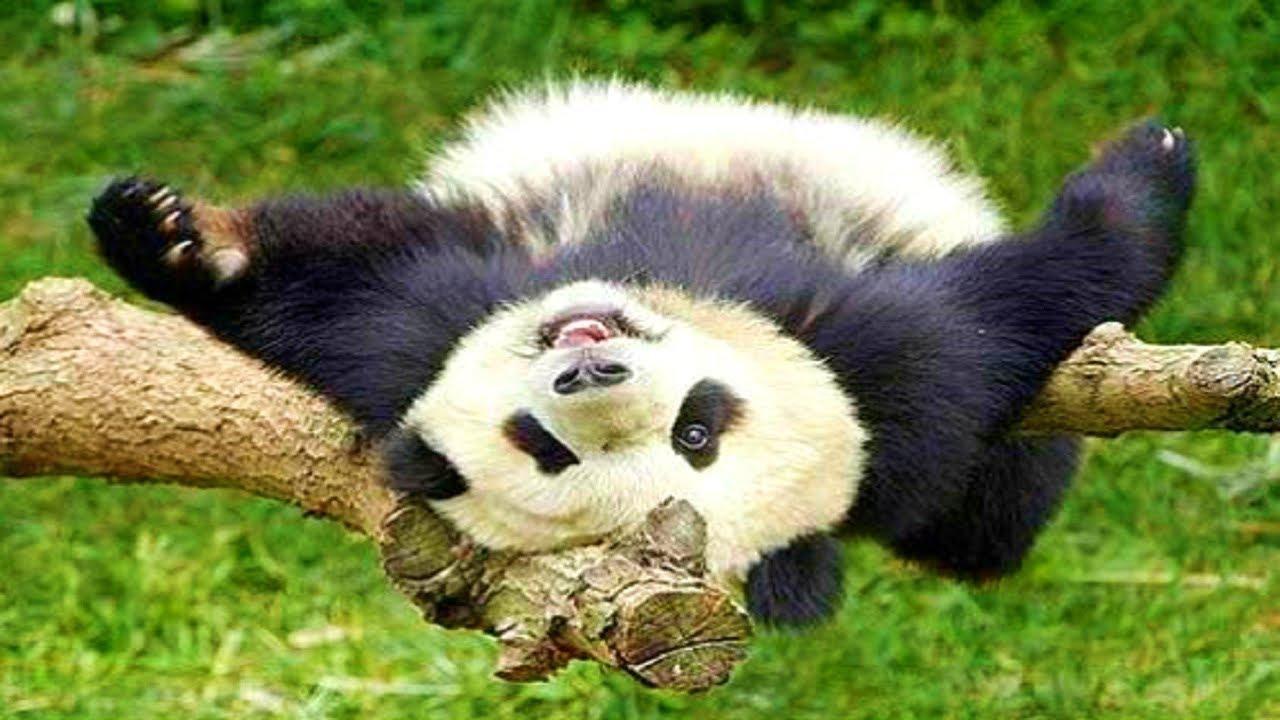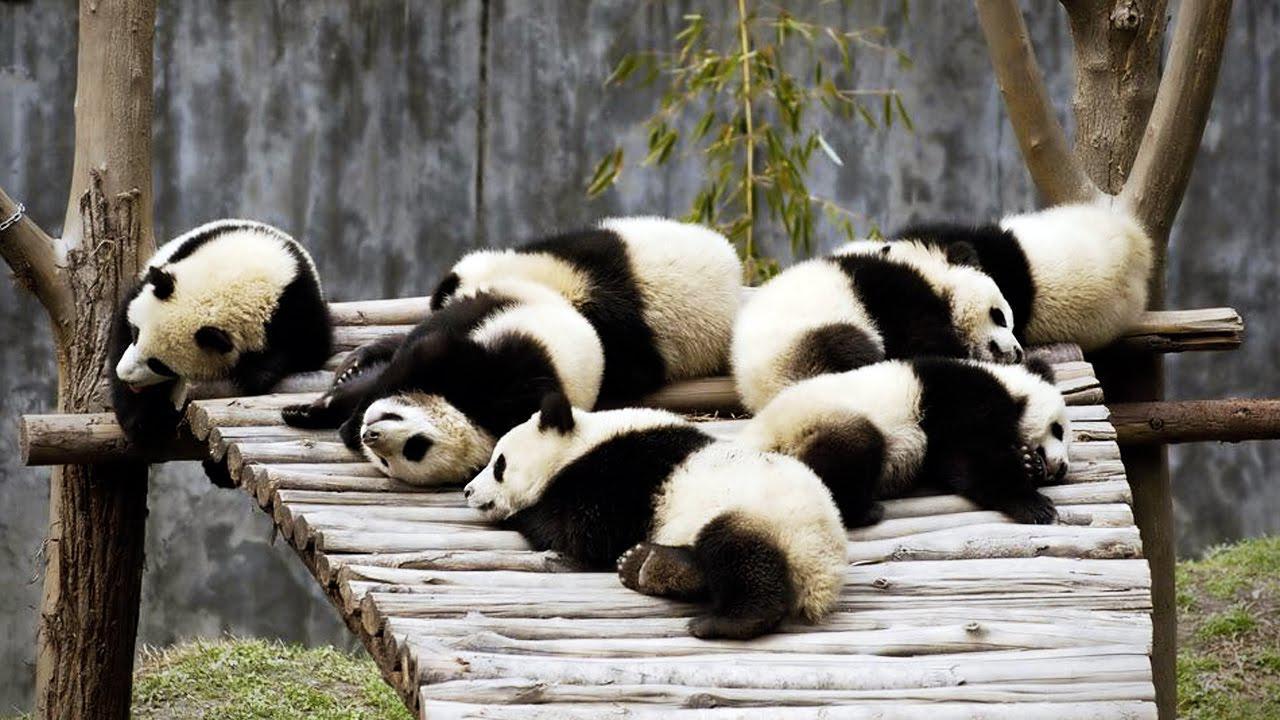The first image is the image on the left, the second image is the image on the right. Considering the images on both sides, is "At least one of the pandas is lying down." valid? Answer yes or no. Yes. The first image is the image on the left, the second image is the image on the right. Examine the images to the left and right. Is the description "In one image, a panda is lying back with its mouth open and tongue showing." accurate? Answer yes or no. Yes. 